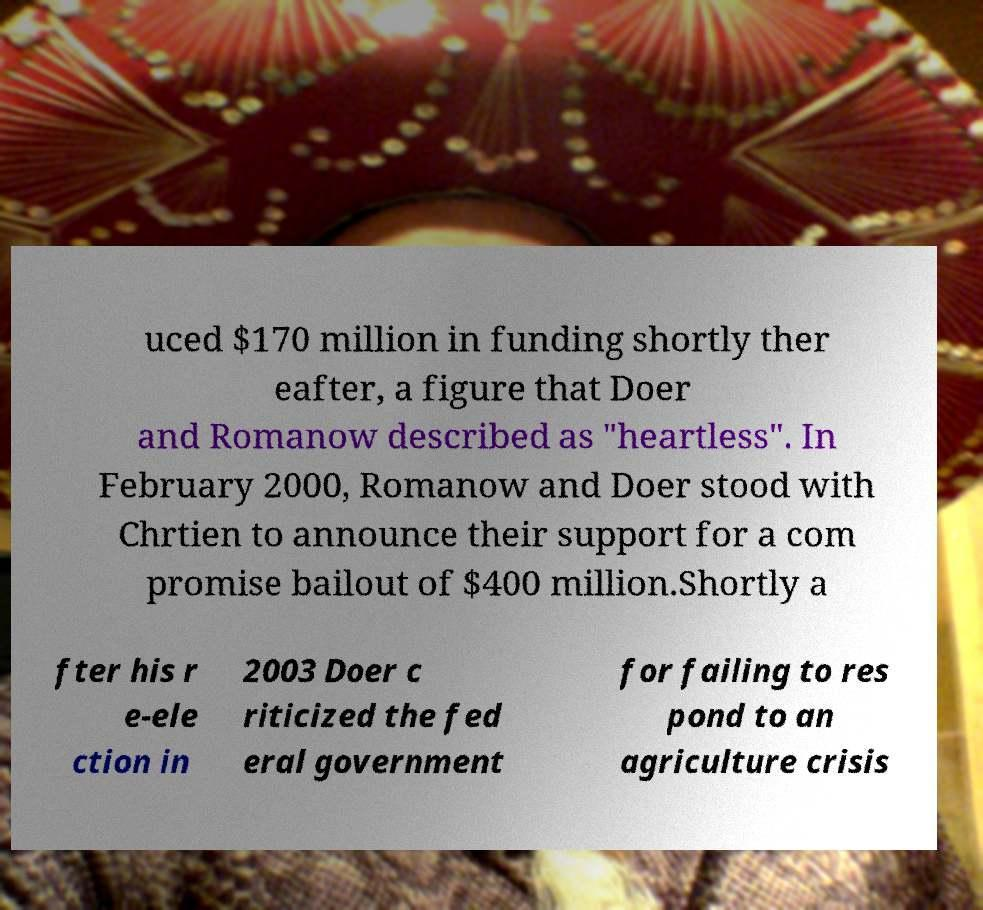There's text embedded in this image that I need extracted. Can you transcribe it verbatim? uced $170 million in funding shortly ther eafter, a figure that Doer and Romanow described as "heartless". In February 2000, Romanow and Doer stood with Chrtien to announce their support for a com promise bailout of $400 million.Shortly a fter his r e-ele ction in 2003 Doer c riticized the fed eral government for failing to res pond to an agriculture crisis 